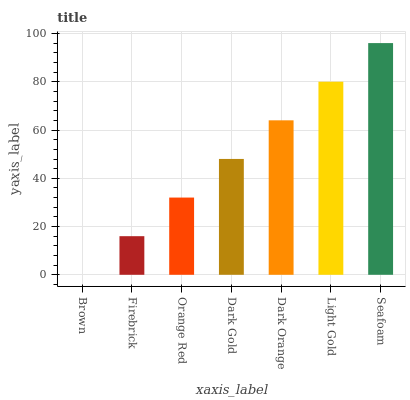Is Brown the minimum?
Answer yes or no. Yes. Is Seafoam the maximum?
Answer yes or no. Yes. Is Firebrick the minimum?
Answer yes or no. No. Is Firebrick the maximum?
Answer yes or no. No. Is Firebrick greater than Brown?
Answer yes or no. Yes. Is Brown less than Firebrick?
Answer yes or no. Yes. Is Brown greater than Firebrick?
Answer yes or no. No. Is Firebrick less than Brown?
Answer yes or no. No. Is Dark Gold the high median?
Answer yes or no. Yes. Is Dark Gold the low median?
Answer yes or no. Yes. Is Dark Orange the high median?
Answer yes or no. No. Is Light Gold the low median?
Answer yes or no. No. 